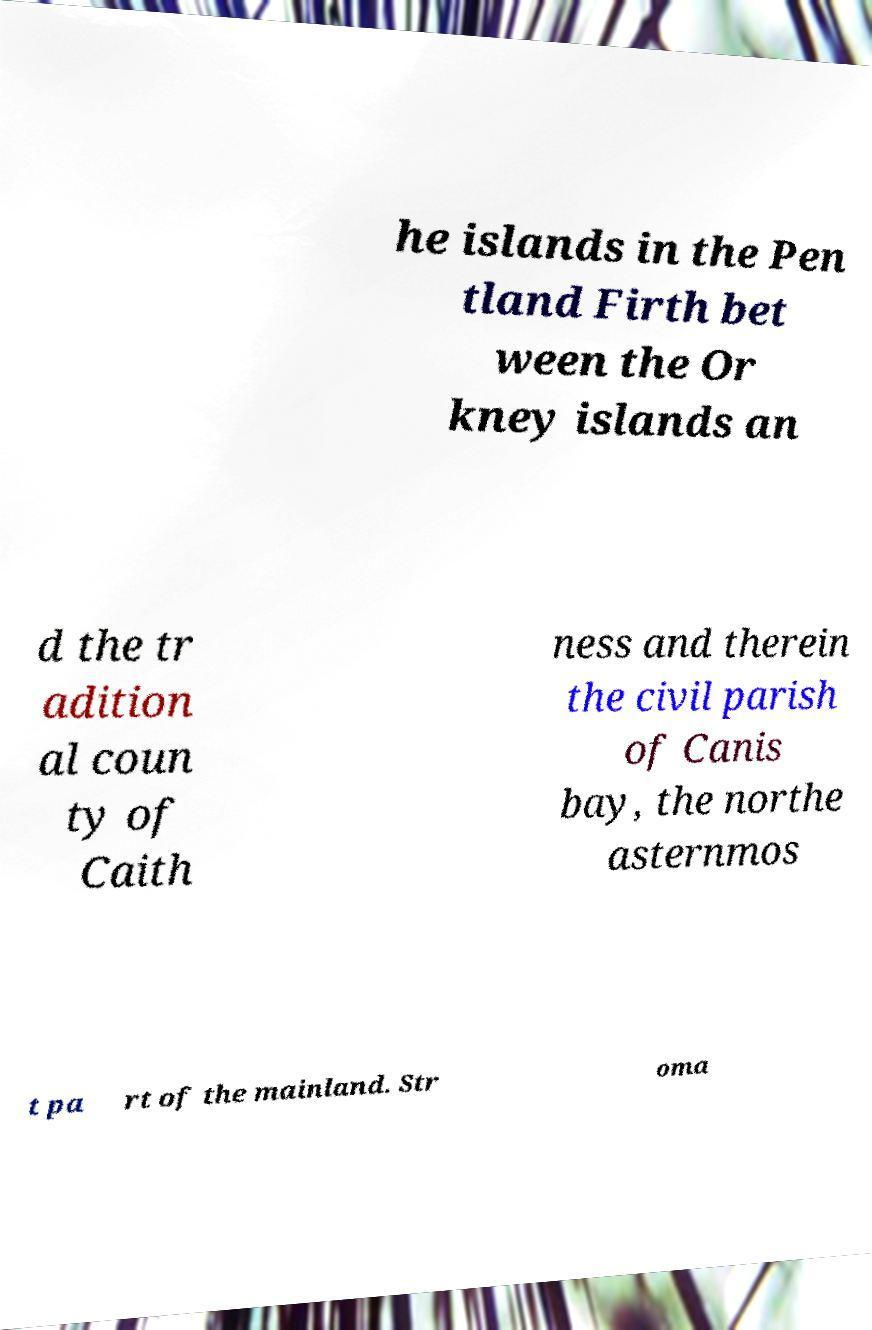I need the written content from this picture converted into text. Can you do that? he islands in the Pen tland Firth bet ween the Or kney islands an d the tr adition al coun ty of Caith ness and therein the civil parish of Canis bay, the northe asternmos t pa rt of the mainland. Str oma 